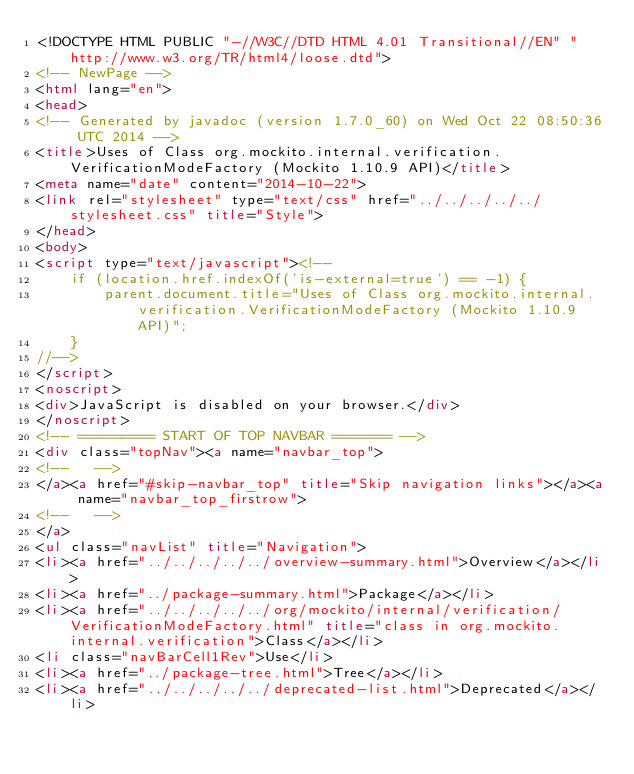Convert code to text. <code><loc_0><loc_0><loc_500><loc_500><_HTML_><!DOCTYPE HTML PUBLIC "-//W3C//DTD HTML 4.01 Transitional//EN" "http://www.w3.org/TR/html4/loose.dtd">
<!-- NewPage -->
<html lang="en">
<head>
<!-- Generated by javadoc (version 1.7.0_60) on Wed Oct 22 08:50:36 UTC 2014 -->
<title>Uses of Class org.mockito.internal.verification.VerificationModeFactory (Mockito 1.10.9 API)</title>
<meta name="date" content="2014-10-22">
<link rel="stylesheet" type="text/css" href="../../../../../stylesheet.css" title="Style">
</head>
<body>
<script type="text/javascript"><!--
    if (location.href.indexOf('is-external=true') == -1) {
        parent.document.title="Uses of Class org.mockito.internal.verification.VerificationModeFactory (Mockito 1.10.9 API)";
    }
//-->
</script>
<noscript>
<div>JavaScript is disabled on your browser.</div>
</noscript>
<!-- ========= START OF TOP NAVBAR ======= -->
<div class="topNav"><a name="navbar_top">
<!--   -->
</a><a href="#skip-navbar_top" title="Skip navigation links"></a><a name="navbar_top_firstrow">
<!--   -->
</a>
<ul class="navList" title="Navigation">
<li><a href="../../../../../overview-summary.html">Overview</a></li>
<li><a href="../package-summary.html">Package</a></li>
<li><a href="../../../../../org/mockito/internal/verification/VerificationModeFactory.html" title="class in org.mockito.internal.verification">Class</a></li>
<li class="navBarCell1Rev">Use</li>
<li><a href="../package-tree.html">Tree</a></li>
<li><a href="../../../../../deprecated-list.html">Deprecated</a></li></code> 